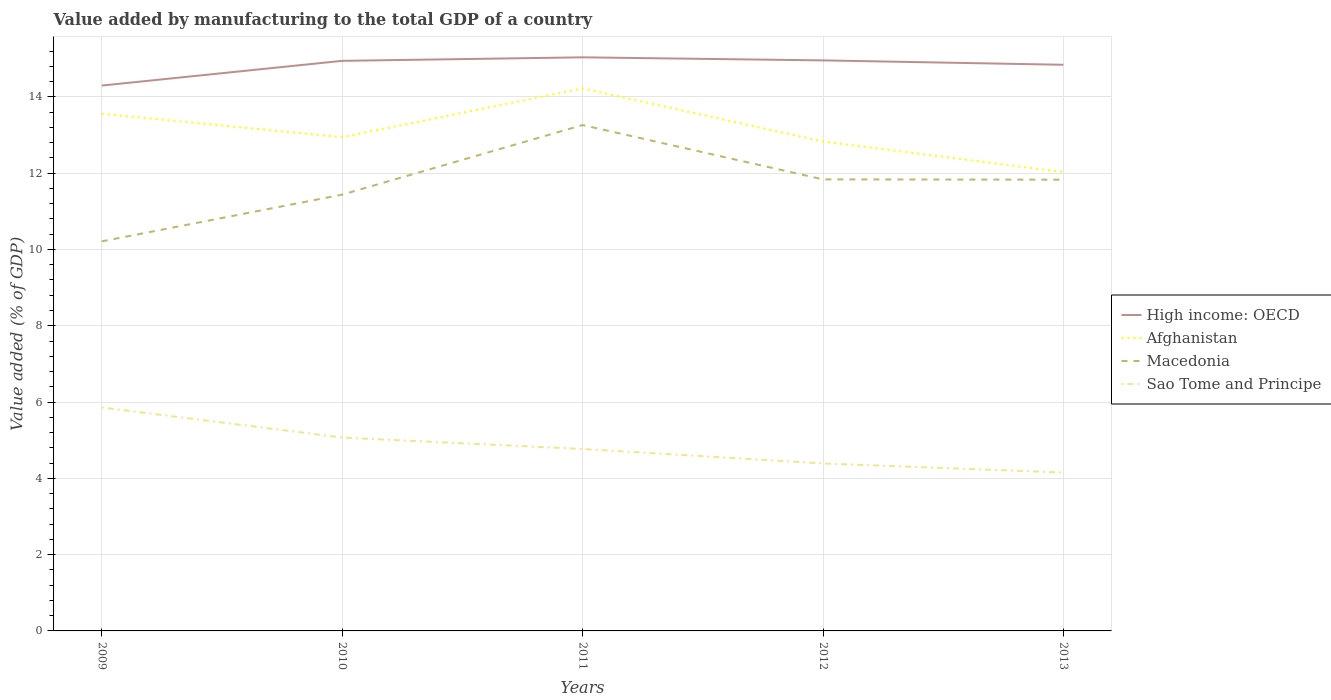Across all years, what is the maximum value added by manufacturing to the total GDP in High income: OECD?
Offer a terse response. 14.3. What is the total value added by manufacturing to the total GDP in Sao Tome and Principe in the graph?
Keep it short and to the point. 0.62. What is the difference between the highest and the second highest value added by manufacturing to the total GDP in Macedonia?
Make the answer very short. 3.05. Is the value added by manufacturing to the total GDP in Macedonia strictly greater than the value added by manufacturing to the total GDP in Sao Tome and Principe over the years?
Offer a very short reply. No. How many lines are there?
Keep it short and to the point. 4. What is the difference between two consecutive major ticks on the Y-axis?
Give a very brief answer. 2. Does the graph contain grids?
Offer a very short reply. Yes. What is the title of the graph?
Your response must be concise. Value added by manufacturing to the total GDP of a country. What is the label or title of the Y-axis?
Give a very brief answer. Value added (% of GDP). What is the Value added (% of GDP) in High income: OECD in 2009?
Offer a very short reply. 14.3. What is the Value added (% of GDP) in Afghanistan in 2009?
Your answer should be compact. 13.56. What is the Value added (% of GDP) in Macedonia in 2009?
Make the answer very short. 10.21. What is the Value added (% of GDP) in Sao Tome and Principe in 2009?
Your response must be concise. 5.86. What is the Value added (% of GDP) in High income: OECD in 2010?
Offer a very short reply. 14.94. What is the Value added (% of GDP) in Afghanistan in 2010?
Ensure brevity in your answer.  12.94. What is the Value added (% of GDP) in Macedonia in 2010?
Your response must be concise. 11.44. What is the Value added (% of GDP) in Sao Tome and Principe in 2010?
Make the answer very short. 5.07. What is the Value added (% of GDP) in High income: OECD in 2011?
Make the answer very short. 15.04. What is the Value added (% of GDP) of Afghanistan in 2011?
Offer a terse response. 14.22. What is the Value added (% of GDP) of Macedonia in 2011?
Provide a short and direct response. 13.26. What is the Value added (% of GDP) of Sao Tome and Principe in 2011?
Your answer should be very brief. 4.77. What is the Value added (% of GDP) of High income: OECD in 2012?
Offer a terse response. 14.96. What is the Value added (% of GDP) in Afghanistan in 2012?
Your answer should be very brief. 12.83. What is the Value added (% of GDP) of Macedonia in 2012?
Your response must be concise. 11.84. What is the Value added (% of GDP) in Sao Tome and Principe in 2012?
Provide a short and direct response. 4.39. What is the Value added (% of GDP) of High income: OECD in 2013?
Your answer should be very brief. 14.84. What is the Value added (% of GDP) in Afghanistan in 2013?
Provide a short and direct response. 12.03. What is the Value added (% of GDP) in Macedonia in 2013?
Make the answer very short. 11.83. What is the Value added (% of GDP) of Sao Tome and Principe in 2013?
Offer a terse response. 4.15. Across all years, what is the maximum Value added (% of GDP) in High income: OECD?
Provide a short and direct response. 15.04. Across all years, what is the maximum Value added (% of GDP) in Afghanistan?
Keep it short and to the point. 14.22. Across all years, what is the maximum Value added (% of GDP) in Macedonia?
Offer a very short reply. 13.26. Across all years, what is the maximum Value added (% of GDP) of Sao Tome and Principe?
Provide a succinct answer. 5.86. Across all years, what is the minimum Value added (% of GDP) in High income: OECD?
Offer a very short reply. 14.3. Across all years, what is the minimum Value added (% of GDP) of Afghanistan?
Your answer should be very brief. 12.03. Across all years, what is the minimum Value added (% of GDP) of Macedonia?
Offer a terse response. 10.21. Across all years, what is the minimum Value added (% of GDP) of Sao Tome and Principe?
Make the answer very short. 4.15. What is the total Value added (% of GDP) in High income: OECD in the graph?
Give a very brief answer. 74.08. What is the total Value added (% of GDP) in Afghanistan in the graph?
Make the answer very short. 65.58. What is the total Value added (% of GDP) in Macedonia in the graph?
Keep it short and to the point. 58.58. What is the total Value added (% of GDP) of Sao Tome and Principe in the graph?
Offer a terse response. 24.24. What is the difference between the Value added (% of GDP) of High income: OECD in 2009 and that in 2010?
Provide a short and direct response. -0.65. What is the difference between the Value added (% of GDP) of Afghanistan in 2009 and that in 2010?
Your answer should be compact. 0.61. What is the difference between the Value added (% of GDP) in Macedonia in 2009 and that in 2010?
Your answer should be very brief. -1.22. What is the difference between the Value added (% of GDP) in Sao Tome and Principe in 2009 and that in 2010?
Offer a terse response. 0.79. What is the difference between the Value added (% of GDP) of High income: OECD in 2009 and that in 2011?
Offer a terse response. -0.74. What is the difference between the Value added (% of GDP) in Afghanistan in 2009 and that in 2011?
Keep it short and to the point. -0.66. What is the difference between the Value added (% of GDP) in Macedonia in 2009 and that in 2011?
Give a very brief answer. -3.05. What is the difference between the Value added (% of GDP) in Sao Tome and Principe in 2009 and that in 2011?
Give a very brief answer. 1.09. What is the difference between the Value added (% of GDP) of High income: OECD in 2009 and that in 2012?
Keep it short and to the point. -0.66. What is the difference between the Value added (% of GDP) of Afghanistan in 2009 and that in 2012?
Make the answer very short. 0.73. What is the difference between the Value added (% of GDP) of Macedonia in 2009 and that in 2012?
Offer a terse response. -1.62. What is the difference between the Value added (% of GDP) of Sao Tome and Principe in 2009 and that in 2012?
Your answer should be very brief. 1.47. What is the difference between the Value added (% of GDP) in High income: OECD in 2009 and that in 2013?
Offer a terse response. -0.54. What is the difference between the Value added (% of GDP) in Afghanistan in 2009 and that in 2013?
Keep it short and to the point. 1.53. What is the difference between the Value added (% of GDP) of Macedonia in 2009 and that in 2013?
Ensure brevity in your answer.  -1.62. What is the difference between the Value added (% of GDP) in Sao Tome and Principe in 2009 and that in 2013?
Provide a succinct answer. 1.71. What is the difference between the Value added (% of GDP) of High income: OECD in 2010 and that in 2011?
Give a very brief answer. -0.09. What is the difference between the Value added (% of GDP) in Afghanistan in 2010 and that in 2011?
Offer a terse response. -1.28. What is the difference between the Value added (% of GDP) in Macedonia in 2010 and that in 2011?
Provide a short and direct response. -1.82. What is the difference between the Value added (% of GDP) of Sao Tome and Principe in 2010 and that in 2011?
Your response must be concise. 0.3. What is the difference between the Value added (% of GDP) of High income: OECD in 2010 and that in 2012?
Offer a very short reply. -0.01. What is the difference between the Value added (% of GDP) in Afghanistan in 2010 and that in 2012?
Provide a short and direct response. 0.11. What is the difference between the Value added (% of GDP) in Macedonia in 2010 and that in 2012?
Give a very brief answer. -0.4. What is the difference between the Value added (% of GDP) in Sao Tome and Principe in 2010 and that in 2012?
Provide a short and direct response. 0.68. What is the difference between the Value added (% of GDP) of High income: OECD in 2010 and that in 2013?
Your response must be concise. 0.1. What is the difference between the Value added (% of GDP) of Afghanistan in 2010 and that in 2013?
Offer a very short reply. 0.91. What is the difference between the Value added (% of GDP) in Macedonia in 2010 and that in 2013?
Provide a short and direct response. -0.39. What is the difference between the Value added (% of GDP) in Sao Tome and Principe in 2010 and that in 2013?
Keep it short and to the point. 0.92. What is the difference between the Value added (% of GDP) of High income: OECD in 2011 and that in 2012?
Keep it short and to the point. 0.08. What is the difference between the Value added (% of GDP) of Afghanistan in 2011 and that in 2012?
Provide a succinct answer. 1.39. What is the difference between the Value added (% of GDP) in Macedonia in 2011 and that in 2012?
Provide a succinct answer. 1.42. What is the difference between the Value added (% of GDP) in Sao Tome and Principe in 2011 and that in 2012?
Keep it short and to the point. 0.38. What is the difference between the Value added (% of GDP) in High income: OECD in 2011 and that in 2013?
Offer a terse response. 0.2. What is the difference between the Value added (% of GDP) of Afghanistan in 2011 and that in 2013?
Ensure brevity in your answer.  2.19. What is the difference between the Value added (% of GDP) of Macedonia in 2011 and that in 2013?
Offer a terse response. 1.43. What is the difference between the Value added (% of GDP) of Sao Tome and Principe in 2011 and that in 2013?
Your response must be concise. 0.62. What is the difference between the Value added (% of GDP) in High income: OECD in 2012 and that in 2013?
Offer a terse response. 0.11. What is the difference between the Value added (% of GDP) of Afghanistan in 2012 and that in 2013?
Give a very brief answer. 0.8. What is the difference between the Value added (% of GDP) in Macedonia in 2012 and that in 2013?
Keep it short and to the point. 0.01. What is the difference between the Value added (% of GDP) in Sao Tome and Principe in 2012 and that in 2013?
Provide a succinct answer. 0.24. What is the difference between the Value added (% of GDP) in High income: OECD in 2009 and the Value added (% of GDP) in Afghanistan in 2010?
Provide a succinct answer. 1.35. What is the difference between the Value added (% of GDP) in High income: OECD in 2009 and the Value added (% of GDP) in Macedonia in 2010?
Your answer should be very brief. 2.86. What is the difference between the Value added (% of GDP) in High income: OECD in 2009 and the Value added (% of GDP) in Sao Tome and Principe in 2010?
Keep it short and to the point. 9.23. What is the difference between the Value added (% of GDP) in Afghanistan in 2009 and the Value added (% of GDP) in Macedonia in 2010?
Make the answer very short. 2.12. What is the difference between the Value added (% of GDP) in Afghanistan in 2009 and the Value added (% of GDP) in Sao Tome and Principe in 2010?
Your answer should be compact. 8.49. What is the difference between the Value added (% of GDP) of Macedonia in 2009 and the Value added (% of GDP) of Sao Tome and Principe in 2010?
Provide a short and direct response. 5.14. What is the difference between the Value added (% of GDP) in High income: OECD in 2009 and the Value added (% of GDP) in Afghanistan in 2011?
Keep it short and to the point. 0.07. What is the difference between the Value added (% of GDP) of High income: OECD in 2009 and the Value added (% of GDP) of Macedonia in 2011?
Give a very brief answer. 1.04. What is the difference between the Value added (% of GDP) in High income: OECD in 2009 and the Value added (% of GDP) in Sao Tome and Principe in 2011?
Your answer should be very brief. 9.53. What is the difference between the Value added (% of GDP) of Afghanistan in 2009 and the Value added (% of GDP) of Macedonia in 2011?
Provide a short and direct response. 0.3. What is the difference between the Value added (% of GDP) of Afghanistan in 2009 and the Value added (% of GDP) of Sao Tome and Principe in 2011?
Provide a short and direct response. 8.79. What is the difference between the Value added (% of GDP) in Macedonia in 2009 and the Value added (% of GDP) in Sao Tome and Principe in 2011?
Provide a short and direct response. 5.44. What is the difference between the Value added (% of GDP) in High income: OECD in 2009 and the Value added (% of GDP) in Afghanistan in 2012?
Offer a very short reply. 1.47. What is the difference between the Value added (% of GDP) of High income: OECD in 2009 and the Value added (% of GDP) of Macedonia in 2012?
Provide a short and direct response. 2.46. What is the difference between the Value added (% of GDP) in High income: OECD in 2009 and the Value added (% of GDP) in Sao Tome and Principe in 2012?
Offer a terse response. 9.91. What is the difference between the Value added (% of GDP) in Afghanistan in 2009 and the Value added (% of GDP) in Macedonia in 2012?
Offer a very short reply. 1.72. What is the difference between the Value added (% of GDP) in Afghanistan in 2009 and the Value added (% of GDP) in Sao Tome and Principe in 2012?
Give a very brief answer. 9.17. What is the difference between the Value added (% of GDP) in Macedonia in 2009 and the Value added (% of GDP) in Sao Tome and Principe in 2012?
Offer a very short reply. 5.82. What is the difference between the Value added (% of GDP) of High income: OECD in 2009 and the Value added (% of GDP) of Afghanistan in 2013?
Offer a very short reply. 2.27. What is the difference between the Value added (% of GDP) in High income: OECD in 2009 and the Value added (% of GDP) in Macedonia in 2013?
Provide a short and direct response. 2.47. What is the difference between the Value added (% of GDP) of High income: OECD in 2009 and the Value added (% of GDP) of Sao Tome and Principe in 2013?
Your answer should be very brief. 10.14. What is the difference between the Value added (% of GDP) in Afghanistan in 2009 and the Value added (% of GDP) in Macedonia in 2013?
Offer a very short reply. 1.73. What is the difference between the Value added (% of GDP) in Afghanistan in 2009 and the Value added (% of GDP) in Sao Tome and Principe in 2013?
Offer a terse response. 9.4. What is the difference between the Value added (% of GDP) in Macedonia in 2009 and the Value added (% of GDP) in Sao Tome and Principe in 2013?
Provide a succinct answer. 6.06. What is the difference between the Value added (% of GDP) of High income: OECD in 2010 and the Value added (% of GDP) of Afghanistan in 2011?
Keep it short and to the point. 0.72. What is the difference between the Value added (% of GDP) of High income: OECD in 2010 and the Value added (% of GDP) of Macedonia in 2011?
Keep it short and to the point. 1.68. What is the difference between the Value added (% of GDP) of High income: OECD in 2010 and the Value added (% of GDP) of Sao Tome and Principe in 2011?
Your answer should be compact. 10.18. What is the difference between the Value added (% of GDP) in Afghanistan in 2010 and the Value added (% of GDP) in Macedonia in 2011?
Give a very brief answer. -0.32. What is the difference between the Value added (% of GDP) of Afghanistan in 2010 and the Value added (% of GDP) of Sao Tome and Principe in 2011?
Keep it short and to the point. 8.17. What is the difference between the Value added (% of GDP) in Macedonia in 2010 and the Value added (% of GDP) in Sao Tome and Principe in 2011?
Your answer should be compact. 6.67. What is the difference between the Value added (% of GDP) in High income: OECD in 2010 and the Value added (% of GDP) in Afghanistan in 2012?
Provide a short and direct response. 2.12. What is the difference between the Value added (% of GDP) of High income: OECD in 2010 and the Value added (% of GDP) of Macedonia in 2012?
Give a very brief answer. 3.11. What is the difference between the Value added (% of GDP) in High income: OECD in 2010 and the Value added (% of GDP) in Sao Tome and Principe in 2012?
Provide a short and direct response. 10.55. What is the difference between the Value added (% of GDP) in Afghanistan in 2010 and the Value added (% of GDP) in Macedonia in 2012?
Keep it short and to the point. 1.11. What is the difference between the Value added (% of GDP) of Afghanistan in 2010 and the Value added (% of GDP) of Sao Tome and Principe in 2012?
Make the answer very short. 8.55. What is the difference between the Value added (% of GDP) of Macedonia in 2010 and the Value added (% of GDP) of Sao Tome and Principe in 2012?
Ensure brevity in your answer.  7.05. What is the difference between the Value added (% of GDP) in High income: OECD in 2010 and the Value added (% of GDP) in Afghanistan in 2013?
Provide a short and direct response. 2.92. What is the difference between the Value added (% of GDP) of High income: OECD in 2010 and the Value added (% of GDP) of Macedonia in 2013?
Provide a short and direct response. 3.12. What is the difference between the Value added (% of GDP) of High income: OECD in 2010 and the Value added (% of GDP) of Sao Tome and Principe in 2013?
Make the answer very short. 10.79. What is the difference between the Value added (% of GDP) in Afghanistan in 2010 and the Value added (% of GDP) in Macedonia in 2013?
Your answer should be compact. 1.11. What is the difference between the Value added (% of GDP) of Afghanistan in 2010 and the Value added (% of GDP) of Sao Tome and Principe in 2013?
Your answer should be very brief. 8.79. What is the difference between the Value added (% of GDP) in Macedonia in 2010 and the Value added (% of GDP) in Sao Tome and Principe in 2013?
Keep it short and to the point. 7.28. What is the difference between the Value added (% of GDP) of High income: OECD in 2011 and the Value added (% of GDP) of Afghanistan in 2012?
Make the answer very short. 2.21. What is the difference between the Value added (% of GDP) of High income: OECD in 2011 and the Value added (% of GDP) of Macedonia in 2012?
Offer a terse response. 3.2. What is the difference between the Value added (% of GDP) of High income: OECD in 2011 and the Value added (% of GDP) of Sao Tome and Principe in 2012?
Your answer should be compact. 10.65. What is the difference between the Value added (% of GDP) in Afghanistan in 2011 and the Value added (% of GDP) in Macedonia in 2012?
Ensure brevity in your answer.  2.39. What is the difference between the Value added (% of GDP) of Afghanistan in 2011 and the Value added (% of GDP) of Sao Tome and Principe in 2012?
Provide a short and direct response. 9.83. What is the difference between the Value added (% of GDP) in Macedonia in 2011 and the Value added (% of GDP) in Sao Tome and Principe in 2012?
Provide a succinct answer. 8.87. What is the difference between the Value added (% of GDP) of High income: OECD in 2011 and the Value added (% of GDP) of Afghanistan in 2013?
Make the answer very short. 3.01. What is the difference between the Value added (% of GDP) of High income: OECD in 2011 and the Value added (% of GDP) of Macedonia in 2013?
Make the answer very short. 3.21. What is the difference between the Value added (% of GDP) of High income: OECD in 2011 and the Value added (% of GDP) of Sao Tome and Principe in 2013?
Provide a succinct answer. 10.88. What is the difference between the Value added (% of GDP) of Afghanistan in 2011 and the Value added (% of GDP) of Macedonia in 2013?
Ensure brevity in your answer.  2.39. What is the difference between the Value added (% of GDP) in Afghanistan in 2011 and the Value added (% of GDP) in Sao Tome and Principe in 2013?
Give a very brief answer. 10.07. What is the difference between the Value added (% of GDP) in Macedonia in 2011 and the Value added (% of GDP) in Sao Tome and Principe in 2013?
Ensure brevity in your answer.  9.11. What is the difference between the Value added (% of GDP) in High income: OECD in 2012 and the Value added (% of GDP) in Afghanistan in 2013?
Ensure brevity in your answer.  2.93. What is the difference between the Value added (% of GDP) in High income: OECD in 2012 and the Value added (% of GDP) in Macedonia in 2013?
Provide a short and direct response. 3.13. What is the difference between the Value added (% of GDP) in High income: OECD in 2012 and the Value added (% of GDP) in Sao Tome and Principe in 2013?
Keep it short and to the point. 10.8. What is the difference between the Value added (% of GDP) of Afghanistan in 2012 and the Value added (% of GDP) of Macedonia in 2013?
Provide a short and direct response. 1. What is the difference between the Value added (% of GDP) in Afghanistan in 2012 and the Value added (% of GDP) in Sao Tome and Principe in 2013?
Your answer should be very brief. 8.68. What is the difference between the Value added (% of GDP) of Macedonia in 2012 and the Value added (% of GDP) of Sao Tome and Principe in 2013?
Your answer should be very brief. 7.68. What is the average Value added (% of GDP) in High income: OECD per year?
Give a very brief answer. 14.82. What is the average Value added (% of GDP) in Afghanistan per year?
Offer a terse response. 13.12. What is the average Value added (% of GDP) of Macedonia per year?
Make the answer very short. 11.72. What is the average Value added (% of GDP) of Sao Tome and Principe per year?
Ensure brevity in your answer.  4.85. In the year 2009, what is the difference between the Value added (% of GDP) in High income: OECD and Value added (% of GDP) in Afghanistan?
Give a very brief answer. 0.74. In the year 2009, what is the difference between the Value added (% of GDP) of High income: OECD and Value added (% of GDP) of Macedonia?
Provide a short and direct response. 4.08. In the year 2009, what is the difference between the Value added (% of GDP) of High income: OECD and Value added (% of GDP) of Sao Tome and Principe?
Keep it short and to the point. 8.44. In the year 2009, what is the difference between the Value added (% of GDP) in Afghanistan and Value added (% of GDP) in Macedonia?
Ensure brevity in your answer.  3.34. In the year 2009, what is the difference between the Value added (% of GDP) of Afghanistan and Value added (% of GDP) of Sao Tome and Principe?
Provide a short and direct response. 7.7. In the year 2009, what is the difference between the Value added (% of GDP) in Macedonia and Value added (% of GDP) in Sao Tome and Principe?
Provide a succinct answer. 4.35. In the year 2010, what is the difference between the Value added (% of GDP) of High income: OECD and Value added (% of GDP) of Afghanistan?
Provide a short and direct response. 2. In the year 2010, what is the difference between the Value added (% of GDP) of High income: OECD and Value added (% of GDP) of Macedonia?
Your answer should be very brief. 3.51. In the year 2010, what is the difference between the Value added (% of GDP) of High income: OECD and Value added (% of GDP) of Sao Tome and Principe?
Your answer should be very brief. 9.88. In the year 2010, what is the difference between the Value added (% of GDP) in Afghanistan and Value added (% of GDP) in Macedonia?
Your response must be concise. 1.51. In the year 2010, what is the difference between the Value added (% of GDP) in Afghanistan and Value added (% of GDP) in Sao Tome and Principe?
Offer a very short reply. 7.87. In the year 2010, what is the difference between the Value added (% of GDP) in Macedonia and Value added (% of GDP) in Sao Tome and Principe?
Offer a terse response. 6.37. In the year 2011, what is the difference between the Value added (% of GDP) in High income: OECD and Value added (% of GDP) in Afghanistan?
Give a very brief answer. 0.81. In the year 2011, what is the difference between the Value added (% of GDP) of High income: OECD and Value added (% of GDP) of Macedonia?
Make the answer very short. 1.78. In the year 2011, what is the difference between the Value added (% of GDP) of High income: OECD and Value added (% of GDP) of Sao Tome and Principe?
Ensure brevity in your answer.  10.27. In the year 2011, what is the difference between the Value added (% of GDP) of Afghanistan and Value added (% of GDP) of Macedonia?
Ensure brevity in your answer.  0.96. In the year 2011, what is the difference between the Value added (% of GDP) in Afghanistan and Value added (% of GDP) in Sao Tome and Principe?
Keep it short and to the point. 9.45. In the year 2011, what is the difference between the Value added (% of GDP) of Macedonia and Value added (% of GDP) of Sao Tome and Principe?
Provide a short and direct response. 8.49. In the year 2012, what is the difference between the Value added (% of GDP) of High income: OECD and Value added (% of GDP) of Afghanistan?
Your response must be concise. 2.13. In the year 2012, what is the difference between the Value added (% of GDP) of High income: OECD and Value added (% of GDP) of Macedonia?
Provide a succinct answer. 3.12. In the year 2012, what is the difference between the Value added (% of GDP) in High income: OECD and Value added (% of GDP) in Sao Tome and Principe?
Your answer should be compact. 10.57. In the year 2012, what is the difference between the Value added (% of GDP) of Afghanistan and Value added (% of GDP) of Macedonia?
Your response must be concise. 0.99. In the year 2012, what is the difference between the Value added (% of GDP) in Afghanistan and Value added (% of GDP) in Sao Tome and Principe?
Offer a very short reply. 8.44. In the year 2012, what is the difference between the Value added (% of GDP) in Macedonia and Value added (% of GDP) in Sao Tome and Principe?
Give a very brief answer. 7.45. In the year 2013, what is the difference between the Value added (% of GDP) of High income: OECD and Value added (% of GDP) of Afghanistan?
Your answer should be very brief. 2.81. In the year 2013, what is the difference between the Value added (% of GDP) of High income: OECD and Value added (% of GDP) of Macedonia?
Offer a very short reply. 3.01. In the year 2013, what is the difference between the Value added (% of GDP) of High income: OECD and Value added (% of GDP) of Sao Tome and Principe?
Provide a succinct answer. 10.69. In the year 2013, what is the difference between the Value added (% of GDP) of Afghanistan and Value added (% of GDP) of Macedonia?
Offer a very short reply. 0.2. In the year 2013, what is the difference between the Value added (% of GDP) in Afghanistan and Value added (% of GDP) in Sao Tome and Principe?
Provide a short and direct response. 7.88. In the year 2013, what is the difference between the Value added (% of GDP) of Macedonia and Value added (% of GDP) of Sao Tome and Principe?
Make the answer very short. 7.68. What is the ratio of the Value added (% of GDP) of High income: OECD in 2009 to that in 2010?
Offer a terse response. 0.96. What is the ratio of the Value added (% of GDP) in Afghanistan in 2009 to that in 2010?
Offer a very short reply. 1.05. What is the ratio of the Value added (% of GDP) in Macedonia in 2009 to that in 2010?
Your answer should be very brief. 0.89. What is the ratio of the Value added (% of GDP) of Sao Tome and Principe in 2009 to that in 2010?
Your answer should be very brief. 1.16. What is the ratio of the Value added (% of GDP) in High income: OECD in 2009 to that in 2011?
Make the answer very short. 0.95. What is the ratio of the Value added (% of GDP) in Afghanistan in 2009 to that in 2011?
Make the answer very short. 0.95. What is the ratio of the Value added (% of GDP) in Macedonia in 2009 to that in 2011?
Provide a succinct answer. 0.77. What is the ratio of the Value added (% of GDP) of Sao Tome and Principe in 2009 to that in 2011?
Provide a succinct answer. 1.23. What is the ratio of the Value added (% of GDP) of High income: OECD in 2009 to that in 2012?
Provide a short and direct response. 0.96. What is the ratio of the Value added (% of GDP) of Afghanistan in 2009 to that in 2012?
Offer a terse response. 1.06. What is the ratio of the Value added (% of GDP) in Macedonia in 2009 to that in 2012?
Offer a very short reply. 0.86. What is the ratio of the Value added (% of GDP) of Sao Tome and Principe in 2009 to that in 2012?
Provide a succinct answer. 1.33. What is the ratio of the Value added (% of GDP) in High income: OECD in 2009 to that in 2013?
Offer a very short reply. 0.96. What is the ratio of the Value added (% of GDP) of Afghanistan in 2009 to that in 2013?
Your answer should be very brief. 1.13. What is the ratio of the Value added (% of GDP) in Macedonia in 2009 to that in 2013?
Your answer should be compact. 0.86. What is the ratio of the Value added (% of GDP) in Sao Tome and Principe in 2009 to that in 2013?
Give a very brief answer. 1.41. What is the ratio of the Value added (% of GDP) of Afghanistan in 2010 to that in 2011?
Make the answer very short. 0.91. What is the ratio of the Value added (% of GDP) of Macedonia in 2010 to that in 2011?
Ensure brevity in your answer.  0.86. What is the ratio of the Value added (% of GDP) of Sao Tome and Principe in 2010 to that in 2011?
Make the answer very short. 1.06. What is the ratio of the Value added (% of GDP) in High income: OECD in 2010 to that in 2012?
Provide a short and direct response. 1. What is the ratio of the Value added (% of GDP) in Afghanistan in 2010 to that in 2012?
Make the answer very short. 1.01. What is the ratio of the Value added (% of GDP) of Macedonia in 2010 to that in 2012?
Your answer should be very brief. 0.97. What is the ratio of the Value added (% of GDP) in Sao Tome and Principe in 2010 to that in 2012?
Provide a succinct answer. 1.15. What is the ratio of the Value added (% of GDP) in Afghanistan in 2010 to that in 2013?
Give a very brief answer. 1.08. What is the ratio of the Value added (% of GDP) in Macedonia in 2010 to that in 2013?
Make the answer very short. 0.97. What is the ratio of the Value added (% of GDP) in Sao Tome and Principe in 2010 to that in 2013?
Your answer should be compact. 1.22. What is the ratio of the Value added (% of GDP) in High income: OECD in 2011 to that in 2012?
Make the answer very short. 1.01. What is the ratio of the Value added (% of GDP) in Afghanistan in 2011 to that in 2012?
Provide a short and direct response. 1.11. What is the ratio of the Value added (% of GDP) in Macedonia in 2011 to that in 2012?
Provide a short and direct response. 1.12. What is the ratio of the Value added (% of GDP) in Sao Tome and Principe in 2011 to that in 2012?
Provide a short and direct response. 1.09. What is the ratio of the Value added (% of GDP) in High income: OECD in 2011 to that in 2013?
Provide a succinct answer. 1.01. What is the ratio of the Value added (% of GDP) in Afghanistan in 2011 to that in 2013?
Give a very brief answer. 1.18. What is the ratio of the Value added (% of GDP) of Macedonia in 2011 to that in 2013?
Offer a very short reply. 1.12. What is the ratio of the Value added (% of GDP) of Sao Tome and Principe in 2011 to that in 2013?
Give a very brief answer. 1.15. What is the ratio of the Value added (% of GDP) of High income: OECD in 2012 to that in 2013?
Give a very brief answer. 1.01. What is the ratio of the Value added (% of GDP) in Afghanistan in 2012 to that in 2013?
Keep it short and to the point. 1.07. What is the ratio of the Value added (% of GDP) of Macedonia in 2012 to that in 2013?
Your answer should be compact. 1. What is the ratio of the Value added (% of GDP) of Sao Tome and Principe in 2012 to that in 2013?
Offer a very short reply. 1.06. What is the difference between the highest and the second highest Value added (% of GDP) in High income: OECD?
Your answer should be very brief. 0.08. What is the difference between the highest and the second highest Value added (% of GDP) in Afghanistan?
Ensure brevity in your answer.  0.66. What is the difference between the highest and the second highest Value added (% of GDP) of Macedonia?
Make the answer very short. 1.42. What is the difference between the highest and the second highest Value added (% of GDP) in Sao Tome and Principe?
Your response must be concise. 0.79. What is the difference between the highest and the lowest Value added (% of GDP) of High income: OECD?
Offer a very short reply. 0.74. What is the difference between the highest and the lowest Value added (% of GDP) of Afghanistan?
Provide a short and direct response. 2.19. What is the difference between the highest and the lowest Value added (% of GDP) in Macedonia?
Your response must be concise. 3.05. What is the difference between the highest and the lowest Value added (% of GDP) of Sao Tome and Principe?
Provide a short and direct response. 1.71. 